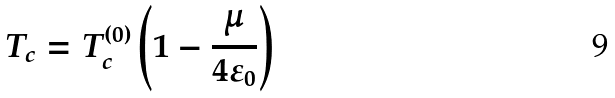Convert formula to latex. <formula><loc_0><loc_0><loc_500><loc_500>T _ { c } = T _ { c } ^ { ( 0 ) } \left ( 1 - \frac { \mu } { 4 \varepsilon _ { 0 } } \right )</formula> 